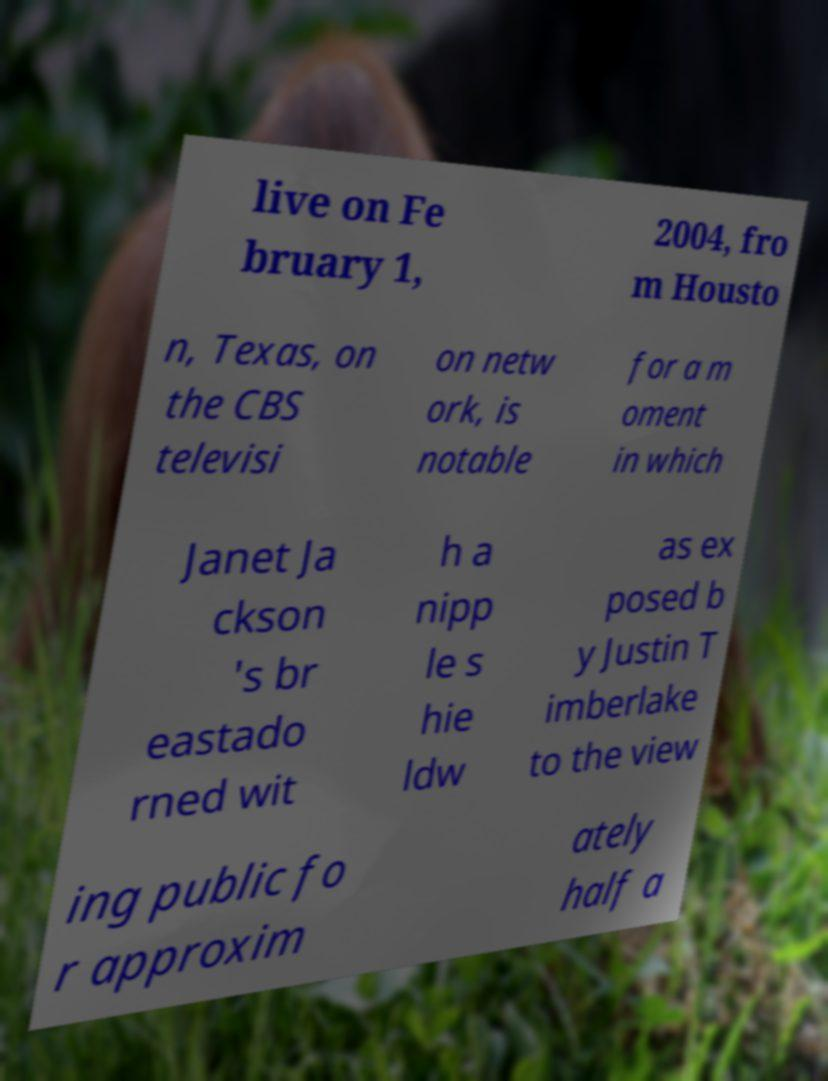Could you assist in decoding the text presented in this image and type it out clearly? live on Fe bruary 1, 2004, fro m Housto n, Texas, on the CBS televisi on netw ork, is notable for a m oment in which Janet Ja ckson 's br eastado rned wit h a nipp le s hie ldw as ex posed b y Justin T imberlake to the view ing public fo r approxim ately half a 